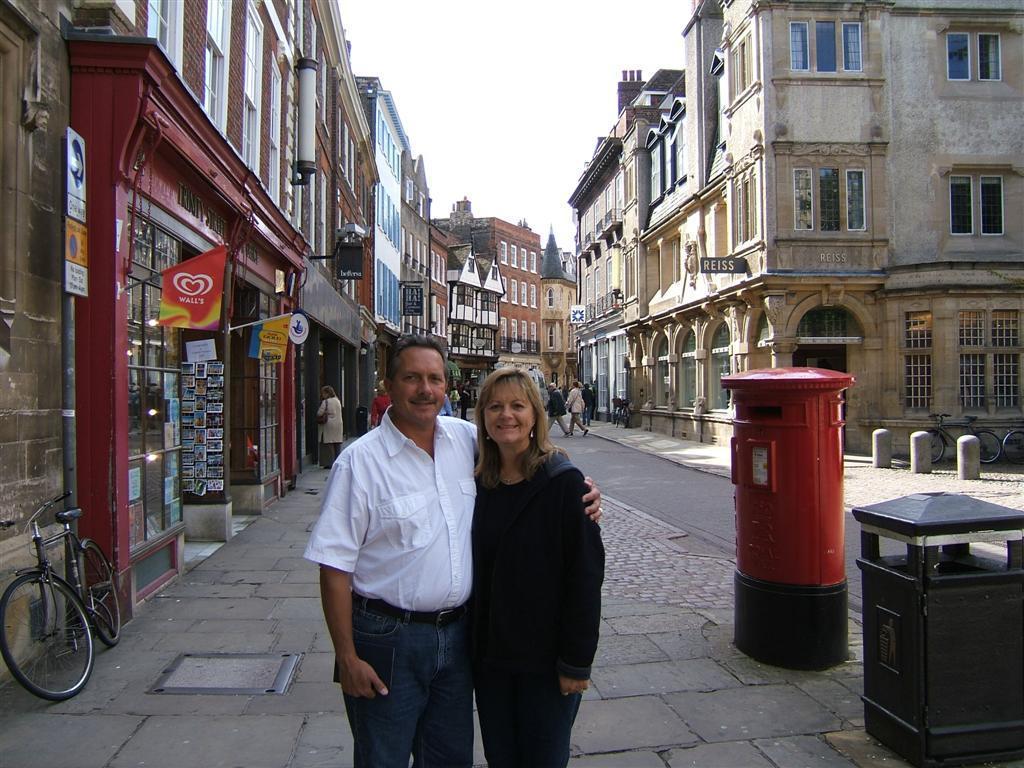In one or two sentences, can you explain what this image depicts? In this image in the front there a persons standing and smiling. In the background there are buildings, there are persons walking, there are boards with some text written on it and on the left side there is a bicycle. On the right side there is a post box which is red in colour and there are bicycles. 